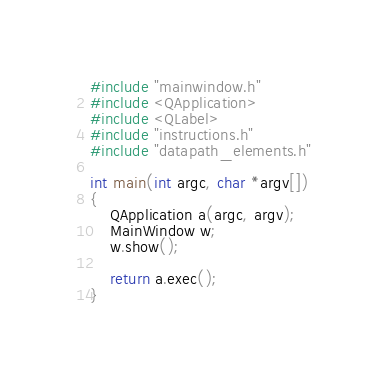Convert code to text. <code><loc_0><loc_0><loc_500><loc_500><_C++_>#include "mainwindow.h"
#include <QApplication>
#include <QLabel>
#include "instructions.h"
#include "datapath_elements.h"

int main(int argc, char *argv[])
{
    QApplication a(argc, argv);
    MainWindow w;
    w.show();

    return a.exec();
}
</code> 